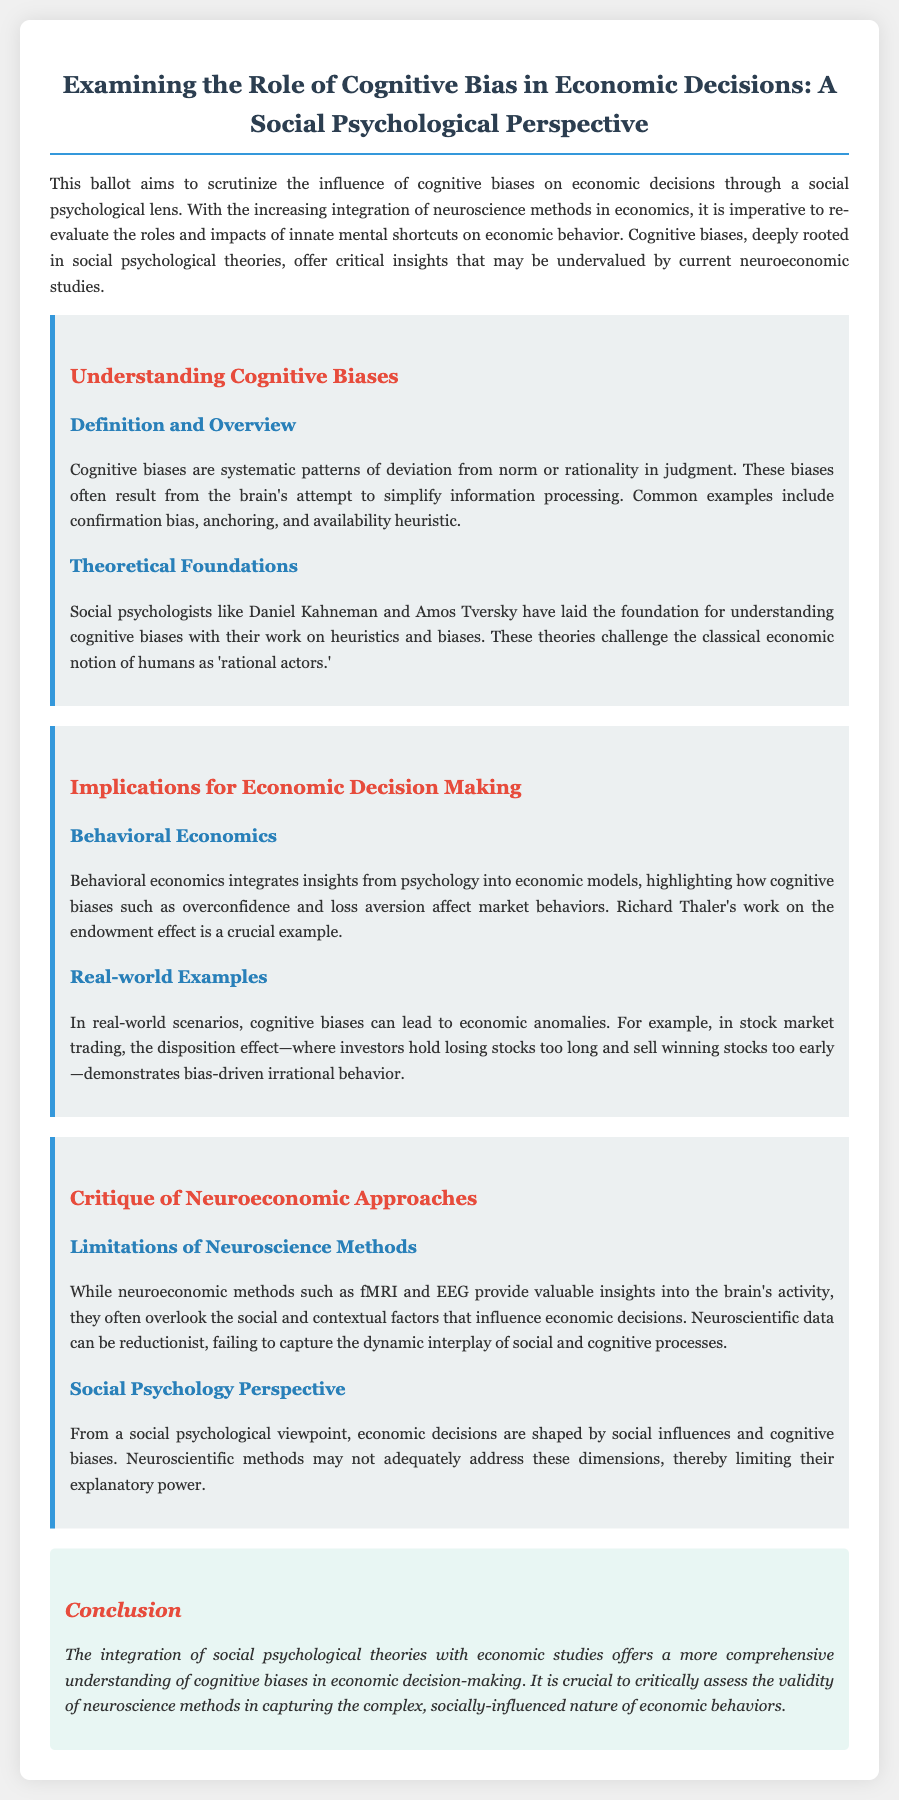what are cognitive biases? Cognitive biases are systematic patterns of deviation from norm or rationality in judgment.
Answer: systematic patterns of deviation who are the foundational figures in cognitive biases? The document mentions social psychologists who have significantly contributed to understanding cognitive biases.
Answer: Daniel Kahneman and Amos Tversky what is an example of behavioral economics mentioned in the document? The document provides a specific example related to market behaviors influenced by cognitive biases.
Answer: endowment effect what is the disposition effect? The disposition effect is a phenomenon in stock market trading where investors exhibit bias-driven irrational behavior.
Answer: investors hold losing stocks too long and sell winning stocks too early what are the limitations of neuroscience methods according to the document? The document describes certain inadequacies of neuroeconomic methods in relation to economic decision-making.
Answer: overlook social and contextual factors what is a critical perspective on neuroeconomic approaches? This question addresses the viewpoint of social psychology regarding neuroscience's impact on economic understanding.
Answer: may not adequately address social influences what is the focus of the conclusion in the document? The conclusion summarizes the document's main argument regarding the integration of different theoretical perspectives.
Answer: integration of social psychological theories with economic studies how do cognitive biases relate to economic anomalies? This question asks for a connection described in the document between biases and real-world economic issues.
Answer: cognitive biases can lead to economic anomalies 